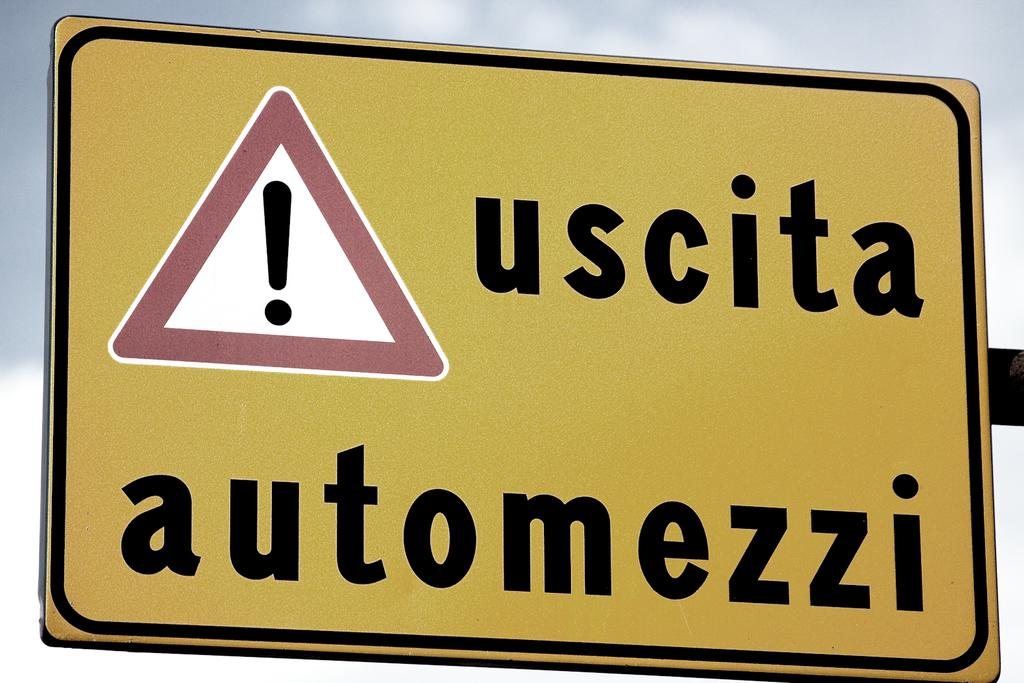Provide a one-sentence caption for the provided image. A traffic caution sign warning for uscita automezzi. 